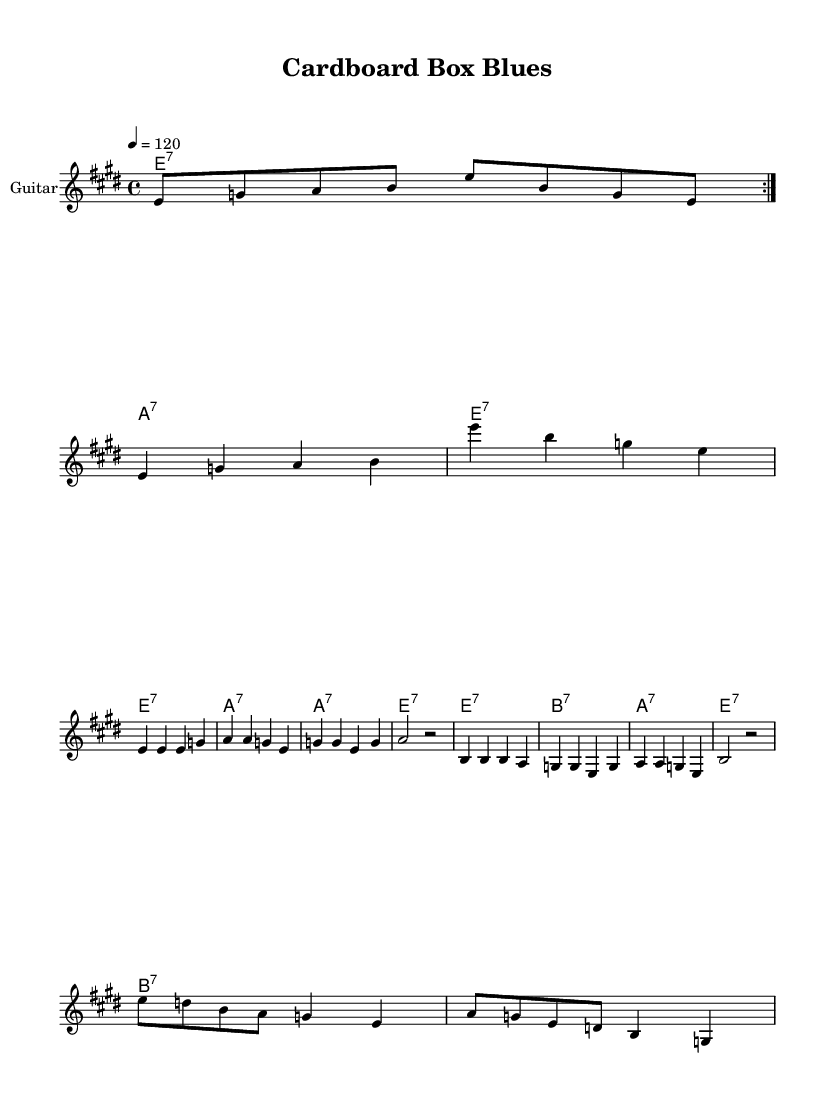What is the key signature of this music? The key signature is E major, which has four sharps: F#, C#, G#, and D#. This can be identified in the music sheet where the key signature is indicated at the beginning.
Answer: E major What is the time signature of this music? The time signature is 4/4, which can be seen at the beginning of the music. This indicates there are four beats in each measure and a quarter note gets one beat.
Answer: 4/4 What is the tempo marking of this music? The tempo marking is 120 beats per minute, which is specified at the beginning of the score written as "4 = 120." This indicates the speed at which the music should be played.
Answer: 120 How many verses are there in the lyrics? There are two verses present in the lyrics section of the music sheet. Each verse is distinctly labeled and can be seen in the lyric sections.
Answer: 2 What is the harmonic structure used in the chorus? The harmonic structure in the chorus primarily utilizes the chords of E7, G7, and A7, as indicated in the chord names section. The repeated use of these chords forms the basis of the melodic composition in the chorus.
Answer: E7, G7, A7 What is the genre of the music? The genre of the music is Electric Blues, as indicated by the title "Cardboard Box Blues" and the style of the musical composition. This genre typically includes a strong guitar presence and expressive vocals.
Answer: Electric Blues 